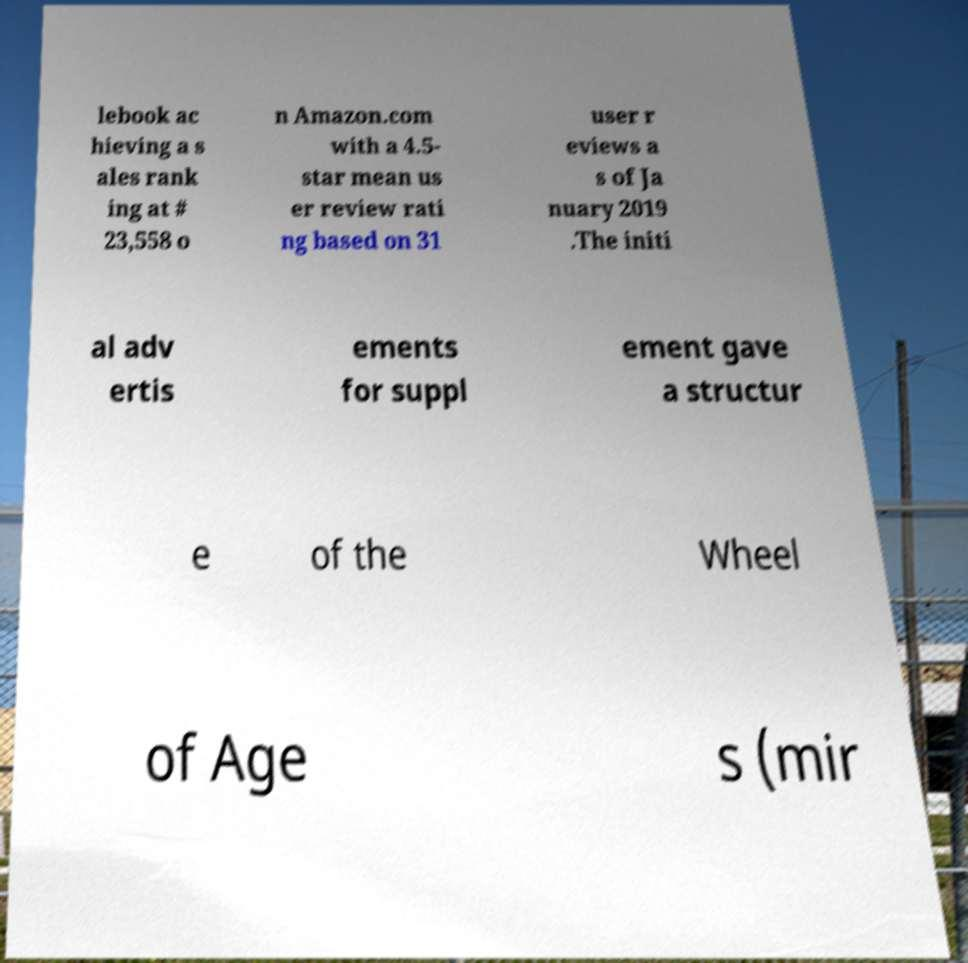Can you read and provide the text displayed in the image?This photo seems to have some interesting text. Can you extract and type it out for me? lebook ac hieving a s ales rank ing at # 23,558 o n Amazon.com with a 4.5- star mean us er review rati ng based on 31 user r eviews a s of Ja nuary 2019 .The initi al adv ertis ements for suppl ement gave a structur e of the Wheel of Age s (mir 